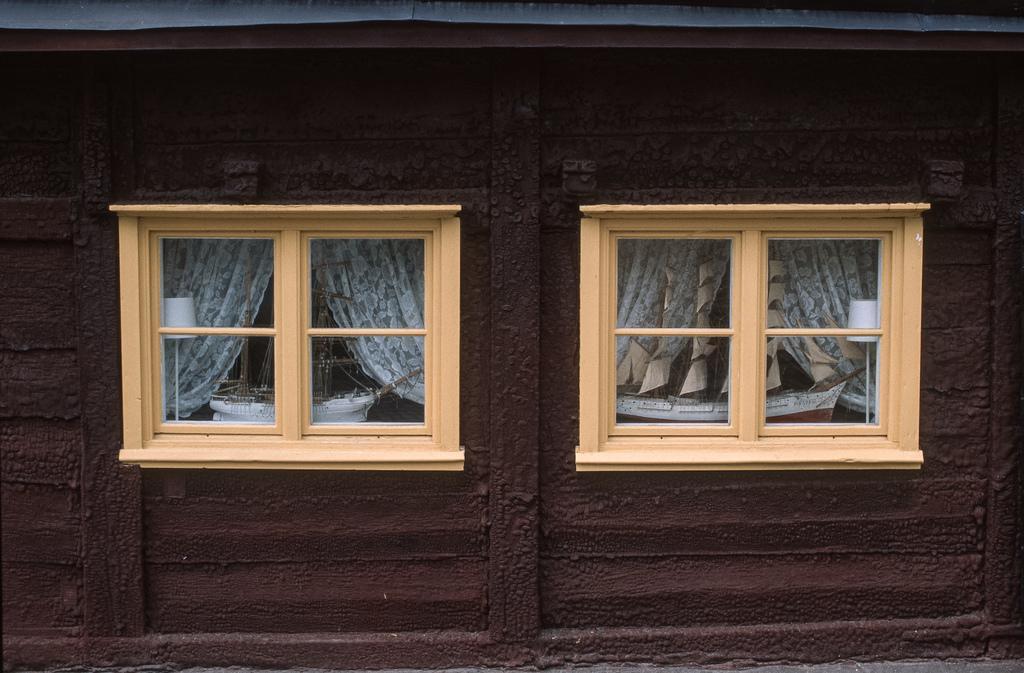Can you describe this image briefly? In this image in the center there are two windows and curtains, and there are through the windows we could see boats, lamp and in the background it looks like a wall. And at the top of the image there is a roof. 